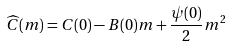<formula> <loc_0><loc_0><loc_500><loc_500>\widehat { C } ( m ) = C ( 0 ) - B ( 0 ) m + \frac { \psi ( 0 ) } { 2 } m ^ { 2 }</formula> 